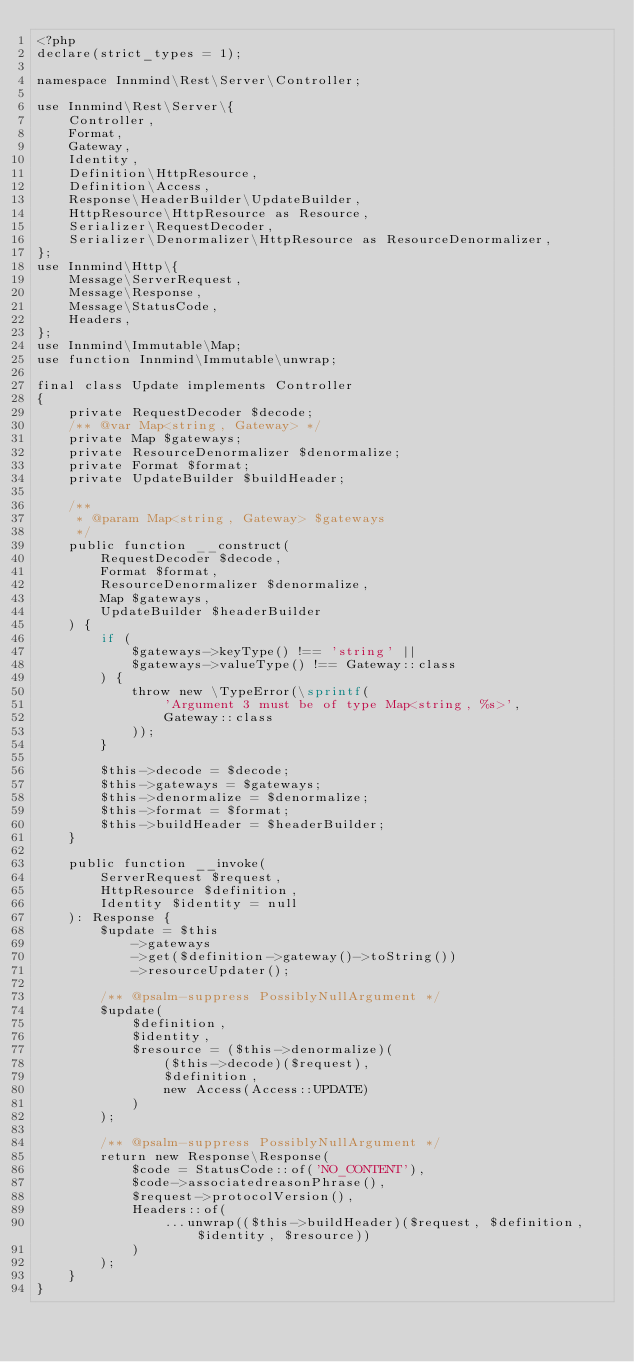Convert code to text. <code><loc_0><loc_0><loc_500><loc_500><_PHP_><?php
declare(strict_types = 1);

namespace Innmind\Rest\Server\Controller;

use Innmind\Rest\Server\{
    Controller,
    Format,
    Gateway,
    Identity,
    Definition\HttpResource,
    Definition\Access,
    Response\HeaderBuilder\UpdateBuilder,
    HttpResource\HttpResource as Resource,
    Serializer\RequestDecoder,
    Serializer\Denormalizer\HttpResource as ResourceDenormalizer,
};
use Innmind\Http\{
    Message\ServerRequest,
    Message\Response,
    Message\StatusCode,
    Headers,
};
use Innmind\Immutable\Map;
use function Innmind\Immutable\unwrap;

final class Update implements Controller
{
    private RequestDecoder $decode;
    /** @var Map<string, Gateway> */
    private Map $gateways;
    private ResourceDenormalizer $denormalize;
    private Format $format;
    private UpdateBuilder $buildHeader;

    /**
     * @param Map<string, Gateway> $gateways
     */
    public function __construct(
        RequestDecoder $decode,
        Format $format,
        ResourceDenormalizer $denormalize,
        Map $gateways,
        UpdateBuilder $headerBuilder
    ) {
        if (
            $gateways->keyType() !== 'string' ||
            $gateways->valueType() !== Gateway::class
        ) {
            throw new \TypeError(\sprintf(
                'Argument 3 must be of type Map<string, %s>',
                Gateway::class
            ));
        }

        $this->decode = $decode;
        $this->gateways = $gateways;
        $this->denormalize = $denormalize;
        $this->format = $format;
        $this->buildHeader = $headerBuilder;
    }

    public function __invoke(
        ServerRequest $request,
        HttpResource $definition,
        Identity $identity = null
    ): Response {
        $update = $this
            ->gateways
            ->get($definition->gateway()->toString())
            ->resourceUpdater();

        /** @psalm-suppress PossiblyNullArgument */
        $update(
            $definition,
            $identity,
            $resource = ($this->denormalize)(
                ($this->decode)($request),
                $definition,
                new Access(Access::UPDATE)
            )
        );

        /** @psalm-suppress PossiblyNullArgument */
        return new Response\Response(
            $code = StatusCode::of('NO_CONTENT'),
            $code->associatedreasonPhrase(),
            $request->protocolVersion(),
            Headers::of(
                ...unwrap(($this->buildHeader)($request, $definition, $identity, $resource))
            )
        );
    }
}
</code> 